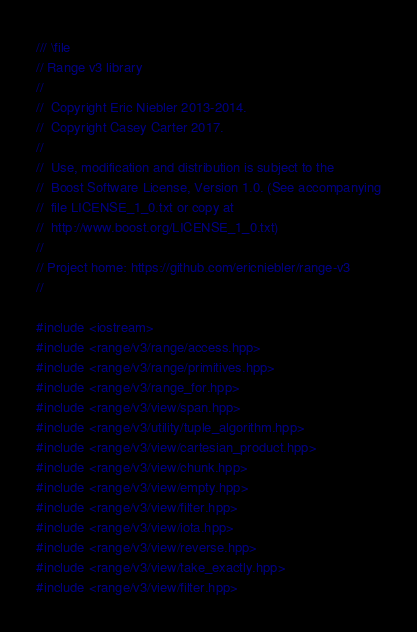Convert code to text. <code><loc_0><loc_0><loc_500><loc_500><_C++_>/// \file
// Range v3 library
//
//  Copyright Eric Niebler 2013-2014.
//  Copyright Casey Carter 2017.
//
//  Use, modification and distribution is subject to the
//  Boost Software License, Version 1.0. (See accompanying
//  file LICENSE_1_0.txt or copy at
//  http://www.boost.org/LICENSE_1_0.txt)
//
// Project home: https://github.com/ericniebler/range-v3
//

#include <iostream>
#include <range/v3/range/access.hpp>
#include <range/v3/range/primitives.hpp>
#include <range/v3/range_for.hpp>
#include <range/v3/view/span.hpp>
#include <range/v3/utility/tuple_algorithm.hpp>
#include <range/v3/view/cartesian_product.hpp>
#include <range/v3/view/chunk.hpp>
#include <range/v3/view/empty.hpp>
#include <range/v3/view/filter.hpp>
#include <range/v3/view/iota.hpp>
#include <range/v3/view/reverse.hpp>
#include <range/v3/view/take_exactly.hpp>
#include <range/v3/view/filter.hpp></code> 